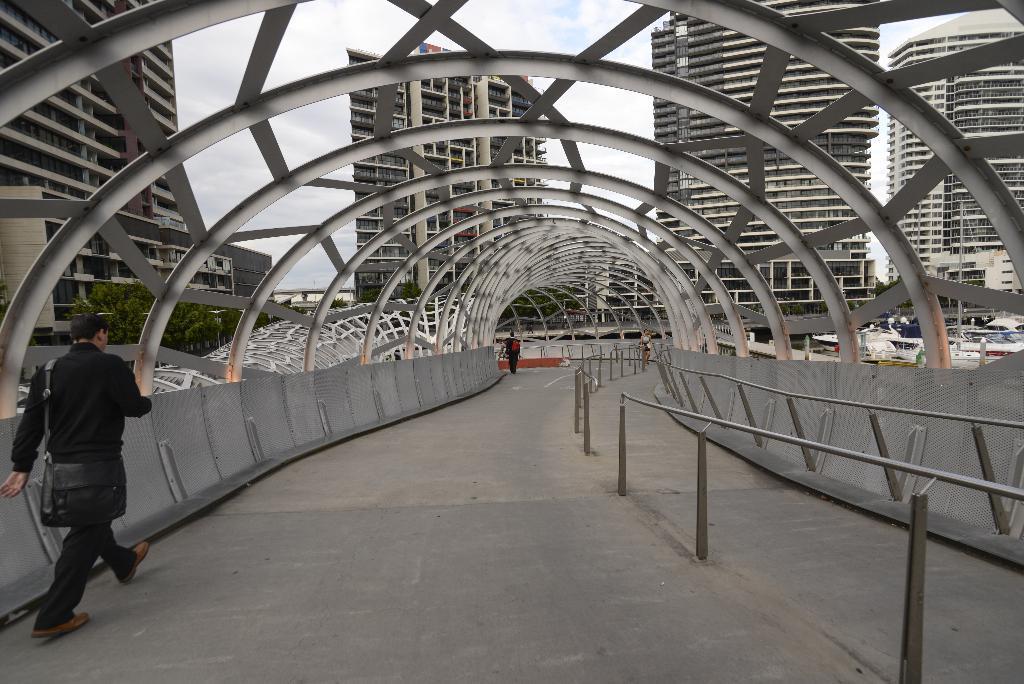Describe this image in one or two sentences. In this image I can see two people with black color dresses and I can see the one person with the bag. These people are walking on the bridge. In the back there are many buildings and the sky. 